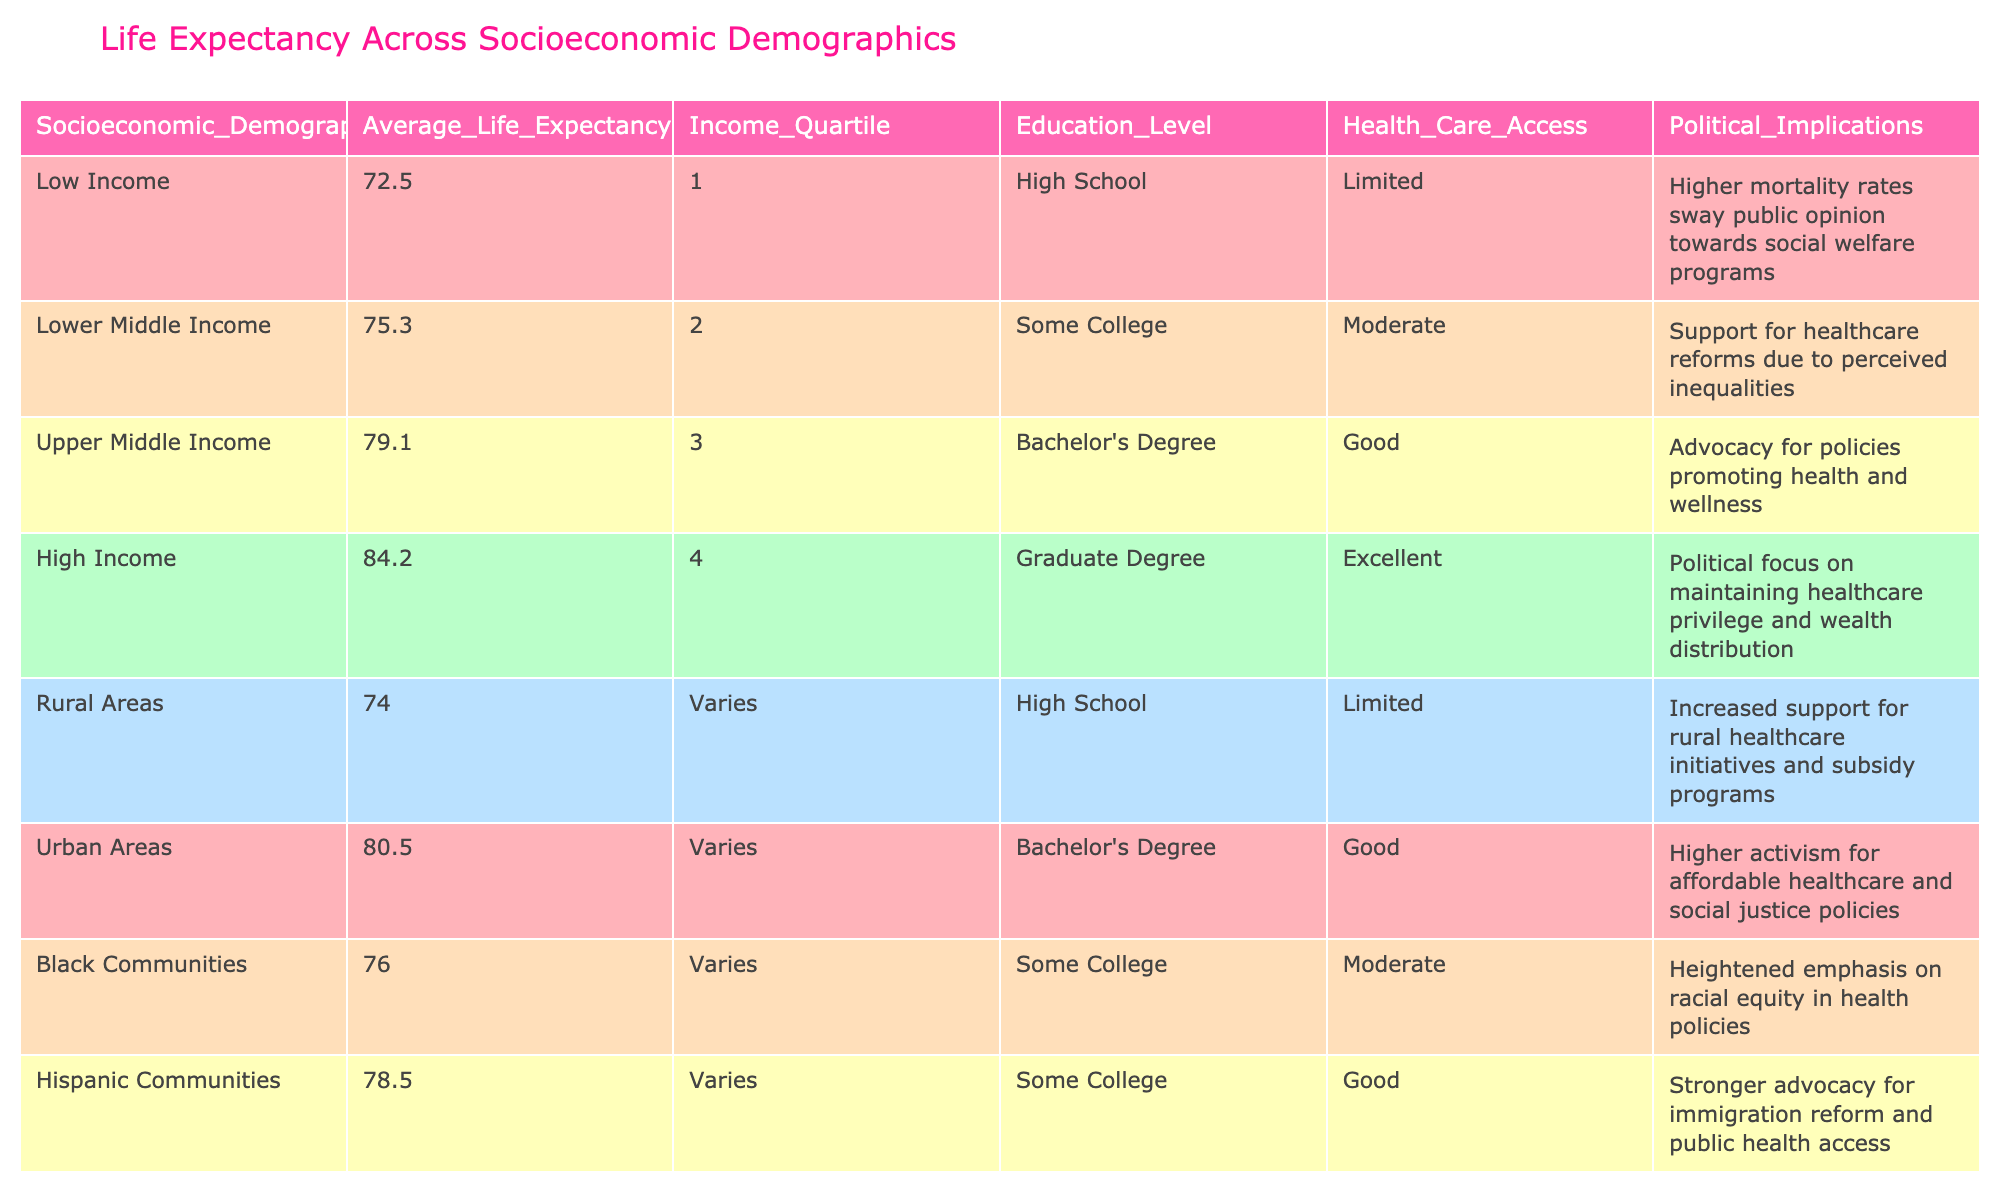What is the average life expectancy of high-income individuals? The table shows that high-income individuals have an average life expectancy of 84.2 years. This value is directly listed in the respective row under the "Average Life Expectancy" column for the "High Income" socioeconomic demographic.
Answer: 84.2 How many socioeconomic demographics have an average life expectancy below 75 years? The table lists four demographics, the "Low Income" (72.5), "Lower Middle Income" (75.3), "Rural Areas" (74.0), and "Black Communities" (76.0). Among these, only "Low Income" and "Rural Areas" have a life expectancy below 75 years, totaling two demographics.
Answer: 2 Is it true that urban areas have a higher average life expectancy than lower middle-income individuals? Yes, urban areas have an average life expectancy of 80.5 years, while lower middle-income individuals have an average life expectancy of 75.3 years. Comparing these two values shows that urban areas live longer.
Answer: Yes What is the average life expectancy of individuals with a graduate degree? According to the table, individuals with a graduate degree (high-income category) have an average life expectancy of 84.2 years. Since this is the only demographic listed with a graduate degree, this value is taken directly from the table.
Answer: 84.2 Which socioeconomic category has the lowest average life expectancy, and what might this suggest politically? The "Low Income" category has the lowest average life expectancy at 72.5 years. This suggests political implications regarding the need for social welfare programs and healthcare reforms due to higher mortality rates in this demographic.
Answer: Low Income, political focus on social welfare programs What is the difference in average life expectancy between the highest and lowest income quartiles? The highest income quartile has an average life expectancy of 84.2 years, while the lowest has 72.5 years. Calculating the difference: 84.2 - 72.5 = 11.7 years. This indicates a significant disparity in life expectancy related to income.
Answer: 11.7 years How does healthcare access correlate with average life expectancy for lower middle income and Hispanic communities? Lower middle-income individuals have moderate healthcare access and an average life expectancy of 75.3 years. In comparison, Hispanic communities have good healthcare access and an average life expectancy of 78.5 years. This suggests that better healthcare access can lead to a higher life expectancy.
Answer: Better healthcare access leads to higher life expectancy What is the combined average life expectancy of rural and urban areas? Rural areas have an average life expectancy of 74.0 years, and urban areas have 80.5 years. To find the combined average: (74.0 + 80.5) / 2 = 77.25 years. This calculation provides insight into the life expectancy differences between these two environments.
Answer: 77.25 years 